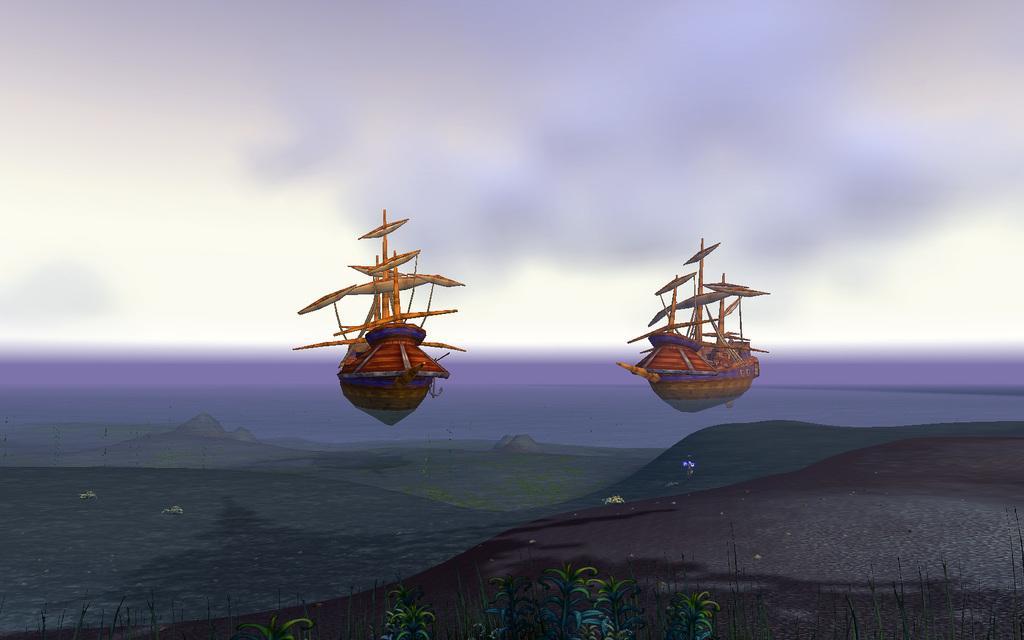In one or two sentences, can you explain what this image depicts? This is an edited and graphical image where there are two boats on the water in the center and the sky is cloudy and there are plants in the front. 